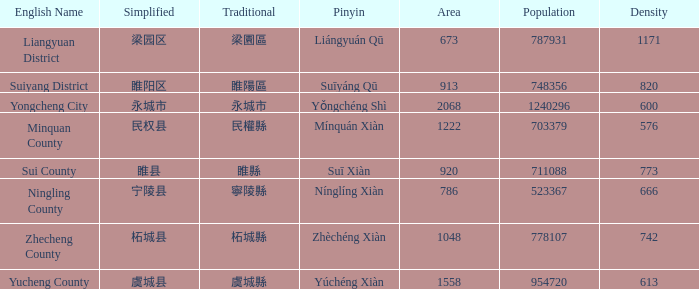How many figures are there for density for Yucheng County? 1.0. 